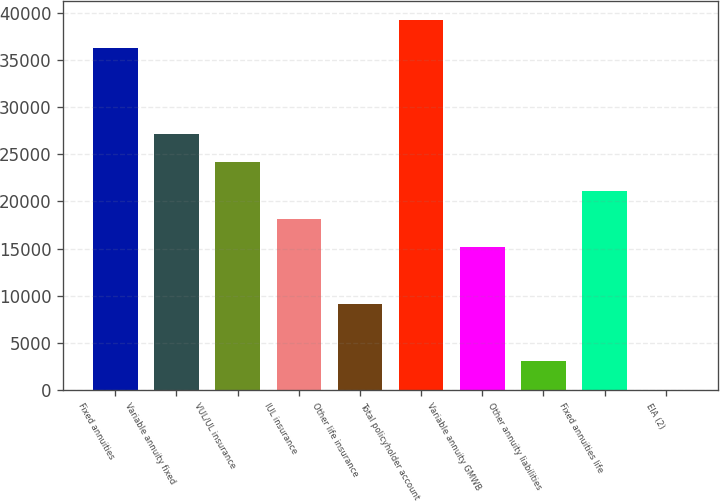Convert chart. <chart><loc_0><loc_0><loc_500><loc_500><bar_chart><fcel>Fixed annuities<fcel>Variable annuity fixed<fcel>VUL/UL insurance<fcel>IUL insurance<fcel>Other life insurance<fcel>Total policyholder account<fcel>Variable annuity GMWB<fcel>Other annuity liabilities<fcel>Fixed annuities life<fcel>EIA (2)<nl><fcel>36237.4<fcel>27184.3<fcel>24166.6<fcel>18131.2<fcel>9078.1<fcel>39255.1<fcel>15113.5<fcel>3042.7<fcel>21148.9<fcel>25<nl></chart> 